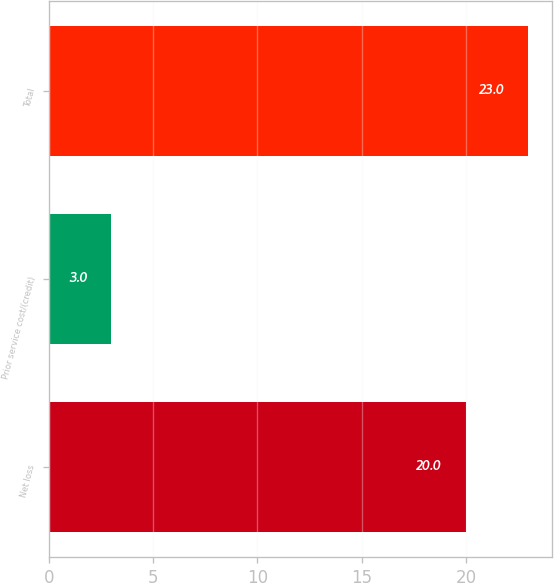<chart> <loc_0><loc_0><loc_500><loc_500><bar_chart><fcel>Net loss<fcel>Prior service cost/(credit)<fcel>Total<nl><fcel>20<fcel>3<fcel>23<nl></chart> 